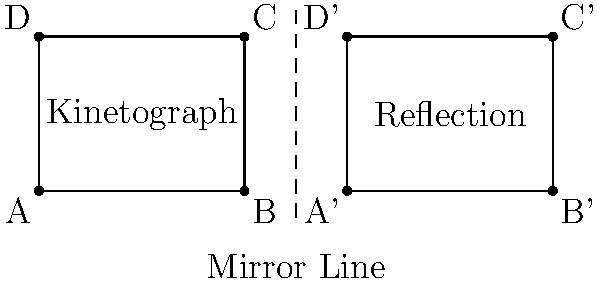In the diagram, Dickson's Kinetograph is represented by rectangle ABCD. If the Kinetograph is reflected across the mirror line, what is the distance between point C and its reflection C'? To solve this problem, we need to follow these steps:

1. Identify the coordinates of point C and its reflection C':
   C is at (4,3)
   C' is at (10,3)

2. The distance between two points can be calculated using the distance formula:
   $$d = \sqrt{(x_2-x_1)^2 + (y_2-y_1)^2}$$

3. Substitute the coordinates into the formula:
   $$d = \sqrt{(10-4)^2 + (3-3)^2}$$

4. Simplify:
   $$d = \sqrt{6^2 + 0^2}$$
   $$d = \sqrt{36 + 0}$$
   $$d = \sqrt{36}$$

5. Calculate the final result:
   $$d = 6$$

Therefore, the distance between point C and its reflection C' is 6 units.
Answer: 6 units 